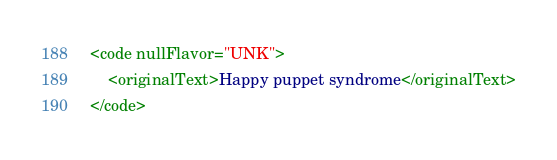Convert code to text. <code><loc_0><loc_0><loc_500><loc_500><_XML_><code nullFlavor="UNK">
	<originalText>Happy puppet syndrome</originalText>
</code></code> 